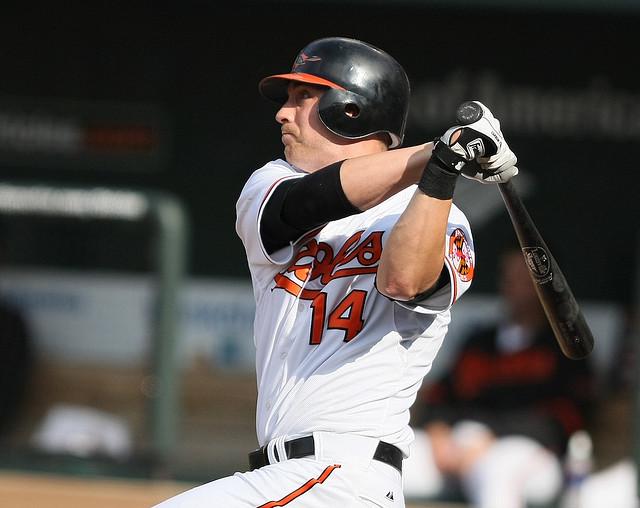What is the guy's Jersey number?
Be succinct. 14. What sport is the man playing?
Be succinct. Baseball. What is cast?
Quick response, please. Baseball. What is the number on the batter's shirt?
Write a very short answer. 14. 